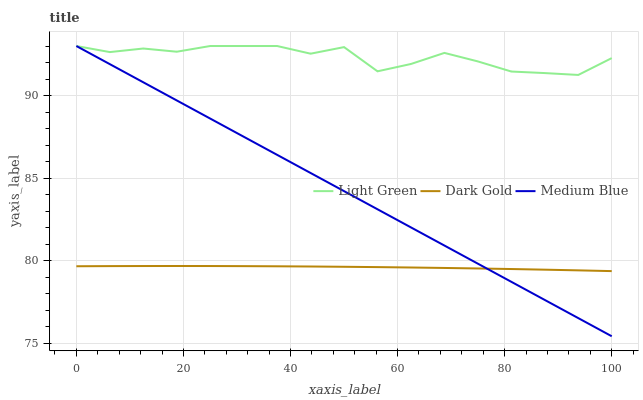Does Dark Gold have the minimum area under the curve?
Answer yes or no. Yes. Does Light Green have the maximum area under the curve?
Answer yes or no. Yes. Does Light Green have the minimum area under the curve?
Answer yes or no. No. Does Dark Gold have the maximum area under the curve?
Answer yes or no. No. Is Medium Blue the smoothest?
Answer yes or no. Yes. Is Light Green the roughest?
Answer yes or no. Yes. Is Dark Gold the smoothest?
Answer yes or no. No. Is Dark Gold the roughest?
Answer yes or no. No. Does Medium Blue have the lowest value?
Answer yes or no. Yes. Does Dark Gold have the lowest value?
Answer yes or no. No. Does Light Green have the highest value?
Answer yes or no. Yes. Does Dark Gold have the highest value?
Answer yes or no. No. Is Dark Gold less than Light Green?
Answer yes or no. Yes. Is Light Green greater than Dark Gold?
Answer yes or no. Yes. Does Medium Blue intersect Light Green?
Answer yes or no. Yes. Is Medium Blue less than Light Green?
Answer yes or no. No. Is Medium Blue greater than Light Green?
Answer yes or no. No. Does Dark Gold intersect Light Green?
Answer yes or no. No. 